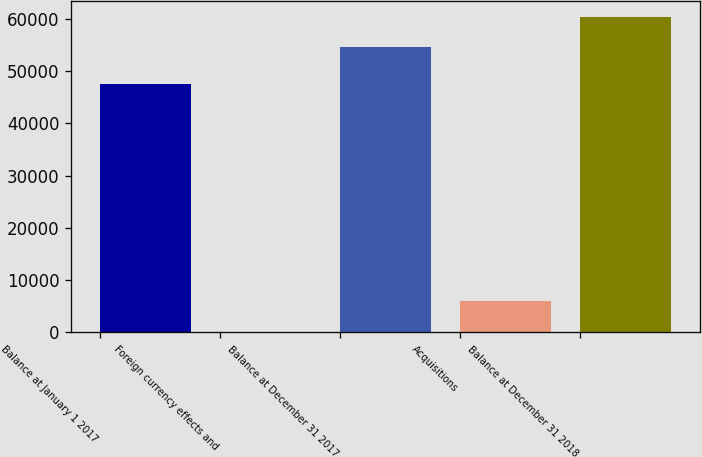Convert chart. <chart><loc_0><loc_0><loc_500><loc_500><bar_chart><fcel>Balance at January 1 2017<fcel>Foreign currency effects and<fcel>Balance at December 31 2017<fcel>Acquisitions<fcel>Balance at December 31 2018<nl><fcel>47584<fcel>128<fcel>54556<fcel>6006.2<fcel>60434.2<nl></chart> 